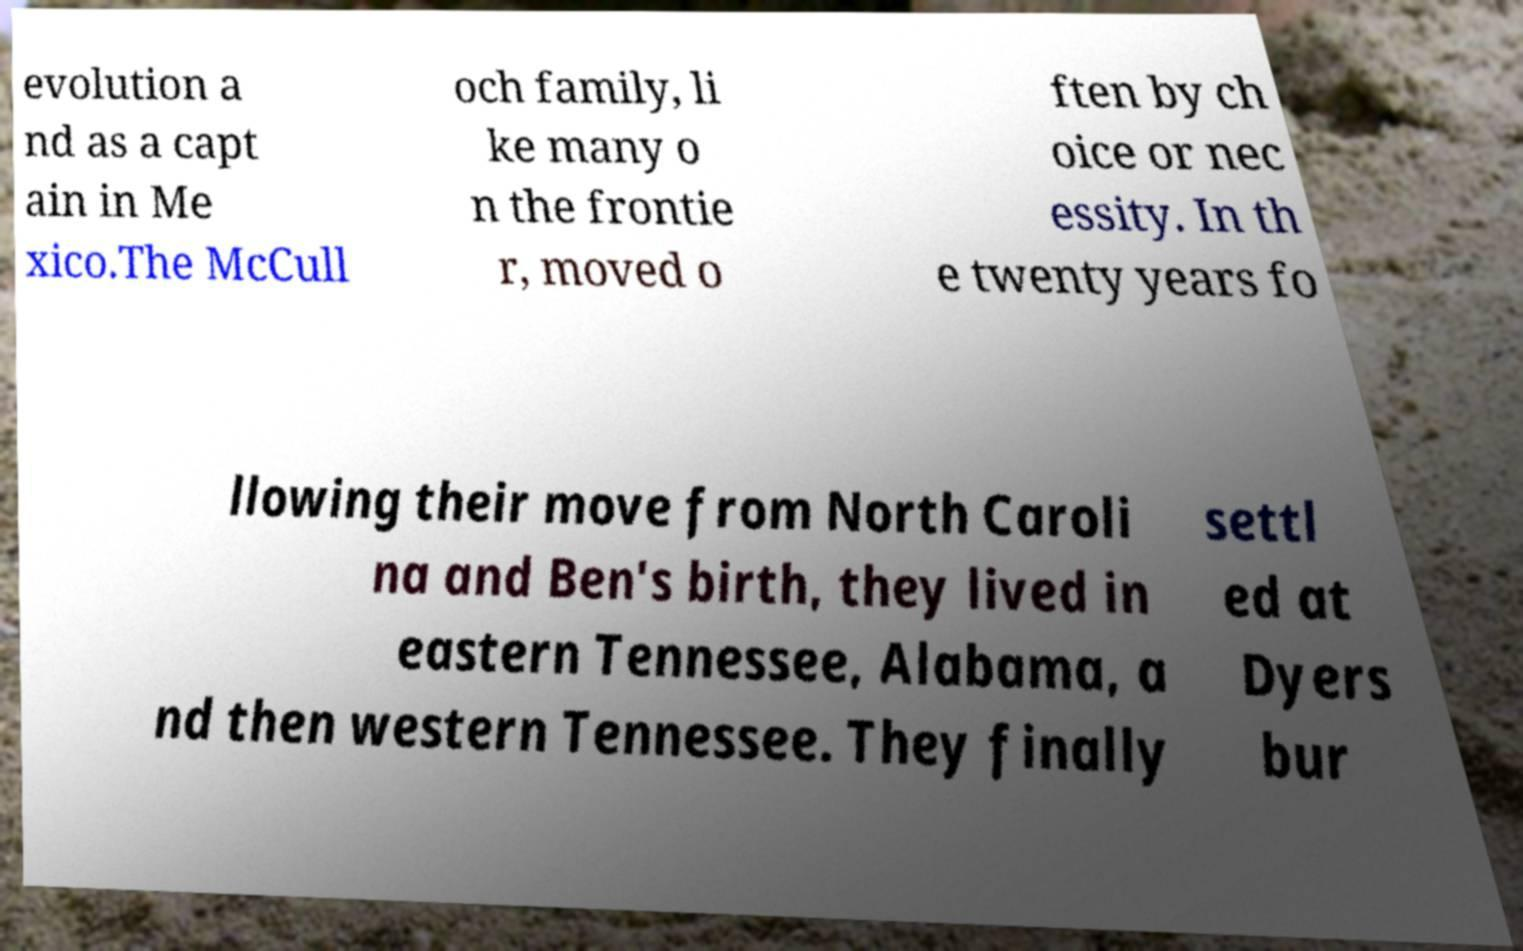There's text embedded in this image that I need extracted. Can you transcribe it verbatim? evolution a nd as a capt ain in Me xico.The McCull och family, li ke many o n the frontie r, moved o ften by ch oice or nec essity. In th e twenty years fo llowing their move from North Caroli na and Ben's birth, they lived in eastern Tennessee, Alabama, a nd then western Tennessee. They finally settl ed at Dyers bur 